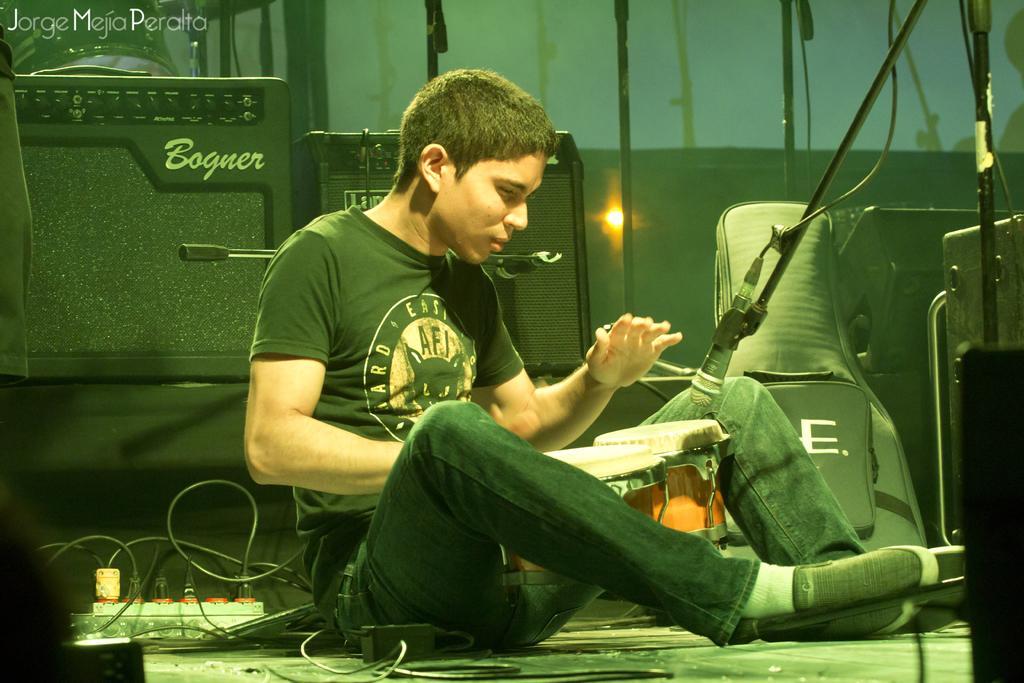Describe this image in one or two sentences. In this picture we can see a man sitting, bag, drums, cables on the floor and in front of him we can see a mic and in the background we can see speakers, some objects. 